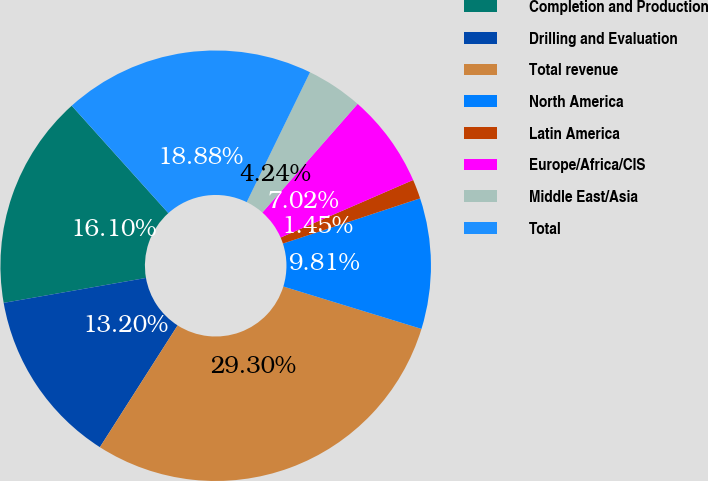Convert chart to OTSL. <chart><loc_0><loc_0><loc_500><loc_500><pie_chart><fcel>Completion and Production<fcel>Drilling and Evaluation<fcel>Total revenue<fcel>North America<fcel>Latin America<fcel>Europe/Africa/CIS<fcel>Middle East/Asia<fcel>Total<nl><fcel>16.1%<fcel>13.2%<fcel>29.3%<fcel>9.81%<fcel>1.45%<fcel>7.02%<fcel>4.24%<fcel>18.88%<nl></chart> 